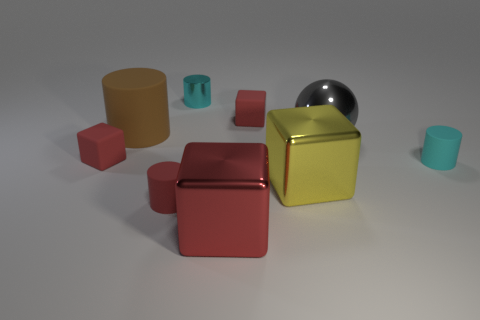Are there more large matte things than small gray rubber cubes?
Your response must be concise. Yes. What number of red objects are behind the small red cylinder and on the right side of the big matte cylinder?
Give a very brief answer. 1. There is a cyan thing that is to the right of the small cyan cylinder that is on the left side of the cyan object to the right of the yellow metal block; what is its shape?
Offer a very short reply. Cylinder. Is there anything else that is the same shape as the large gray metal thing?
Provide a succinct answer. No. What number of cylinders are brown things or gray metal things?
Provide a succinct answer. 1. There is a matte block in front of the large brown thing; does it have the same color as the large ball?
Provide a succinct answer. No. The tiny red thing in front of the small cyan object that is on the right side of the small cyan cylinder that is on the left side of the big yellow metal cube is made of what material?
Keep it short and to the point. Rubber. Do the red metal thing and the yellow object have the same size?
Ensure brevity in your answer.  Yes. There is a shiny cylinder; does it have the same color as the tiny cylinder that is right of the gray metal object?
Offer a terse response. Yes. What is the shape of the large yellow thing that is the same material as the ball?
Your answer should be compact. Cube. 